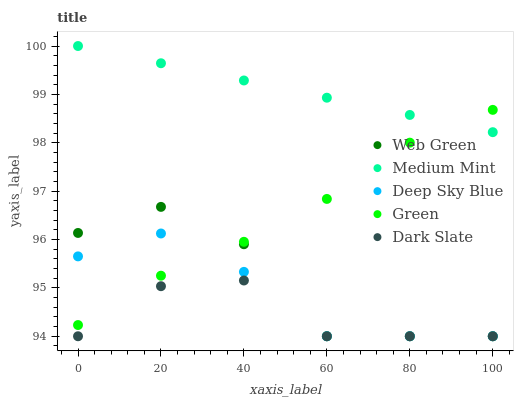Does Dark Slate have the minimum area under the curve?
Answer yes or no. Yes. Does Medium Mint have the maximum area under the curve?
Answer yes or no. Yes. Does Green have the minimum area under the curve?
Answer yes or no. No. Does Green have the maximum area under the curve?
Answer yes or no. No. Is Medium Mint the smoothest?
Answer yes or no. Yes. Is Web Green the roughest?
Answer yes or no. Yes. Is Dark Slate the smoothest?
Answer yes or no. No. Is Dark Slate the roughest?
Answer yes or no. No. Does Dark Slate have the lowest value?
Answer yes or no. Yes. Does Green have the lowest value?
Answer yes or no. No. Does Medium Mint have the highest value?
Answer yes or no. Yes. Does Green have the highest value?
Answer yes or no. No. Is Web Green less than Medium Mint?
Answer yes or no. Yes. Is Medium Mint greater than Web Green?
Answer yes or no. Yes. Does Dark Slate intersect Web Green?
Answer yes or no. Yes. Is Dark Slate less than Web Green?
Answer yes or no. No. Is Dark Slate greater than Web Green?
Answer yes or no. No. Does Web Green intersect Medium Mint?
Answer yes or no. No. 